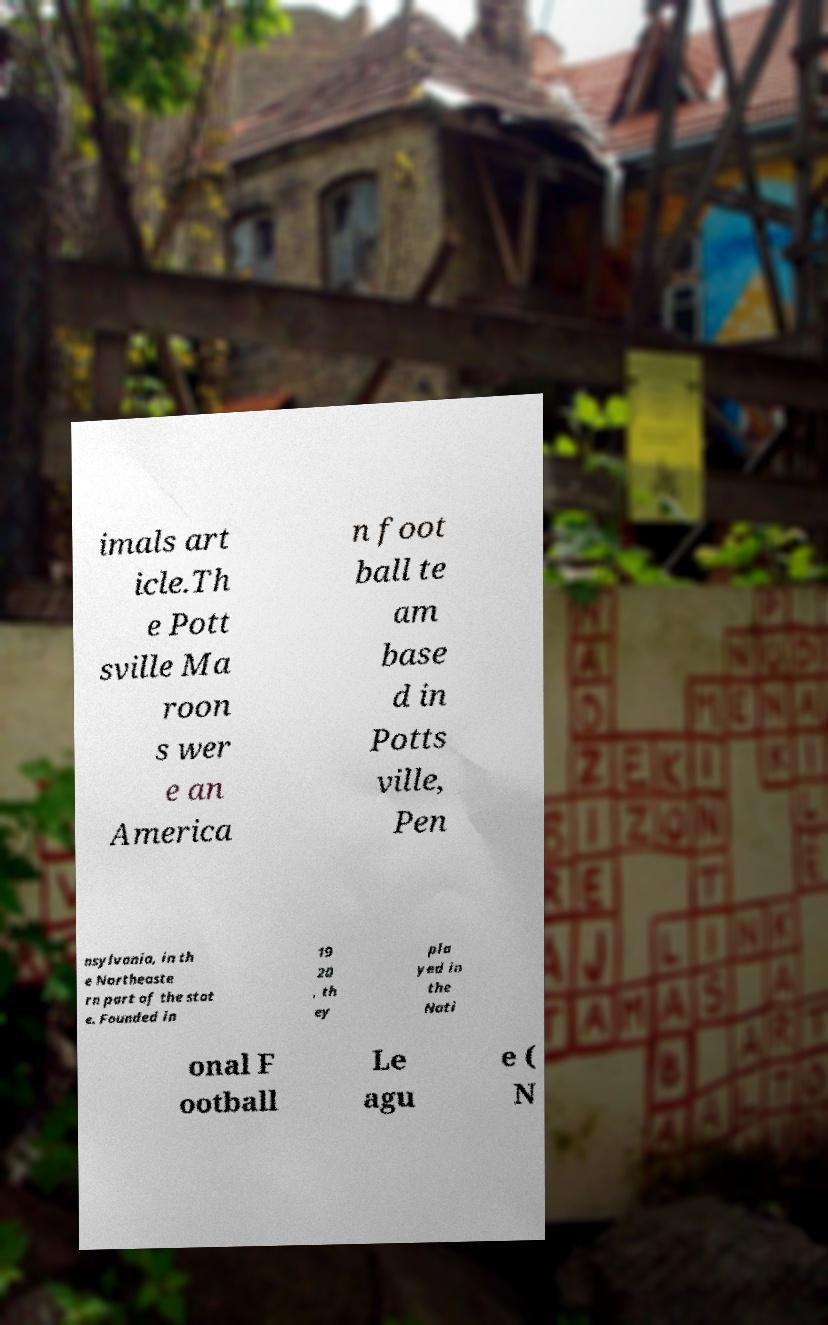Can you read and provide the text displayed in the image?This photo seems to have some interesting text. Can you extract and type it out for me? imals art icle.Th e Pott sville Ma roon s wer e an America n foot ball te am base d in Potts ville, Pen nsylvania, in th e Northeaste rn part of the stat e. Founded in 19 20 , th ey pla yed in the Nati onal F ootball Le agu e ( N 